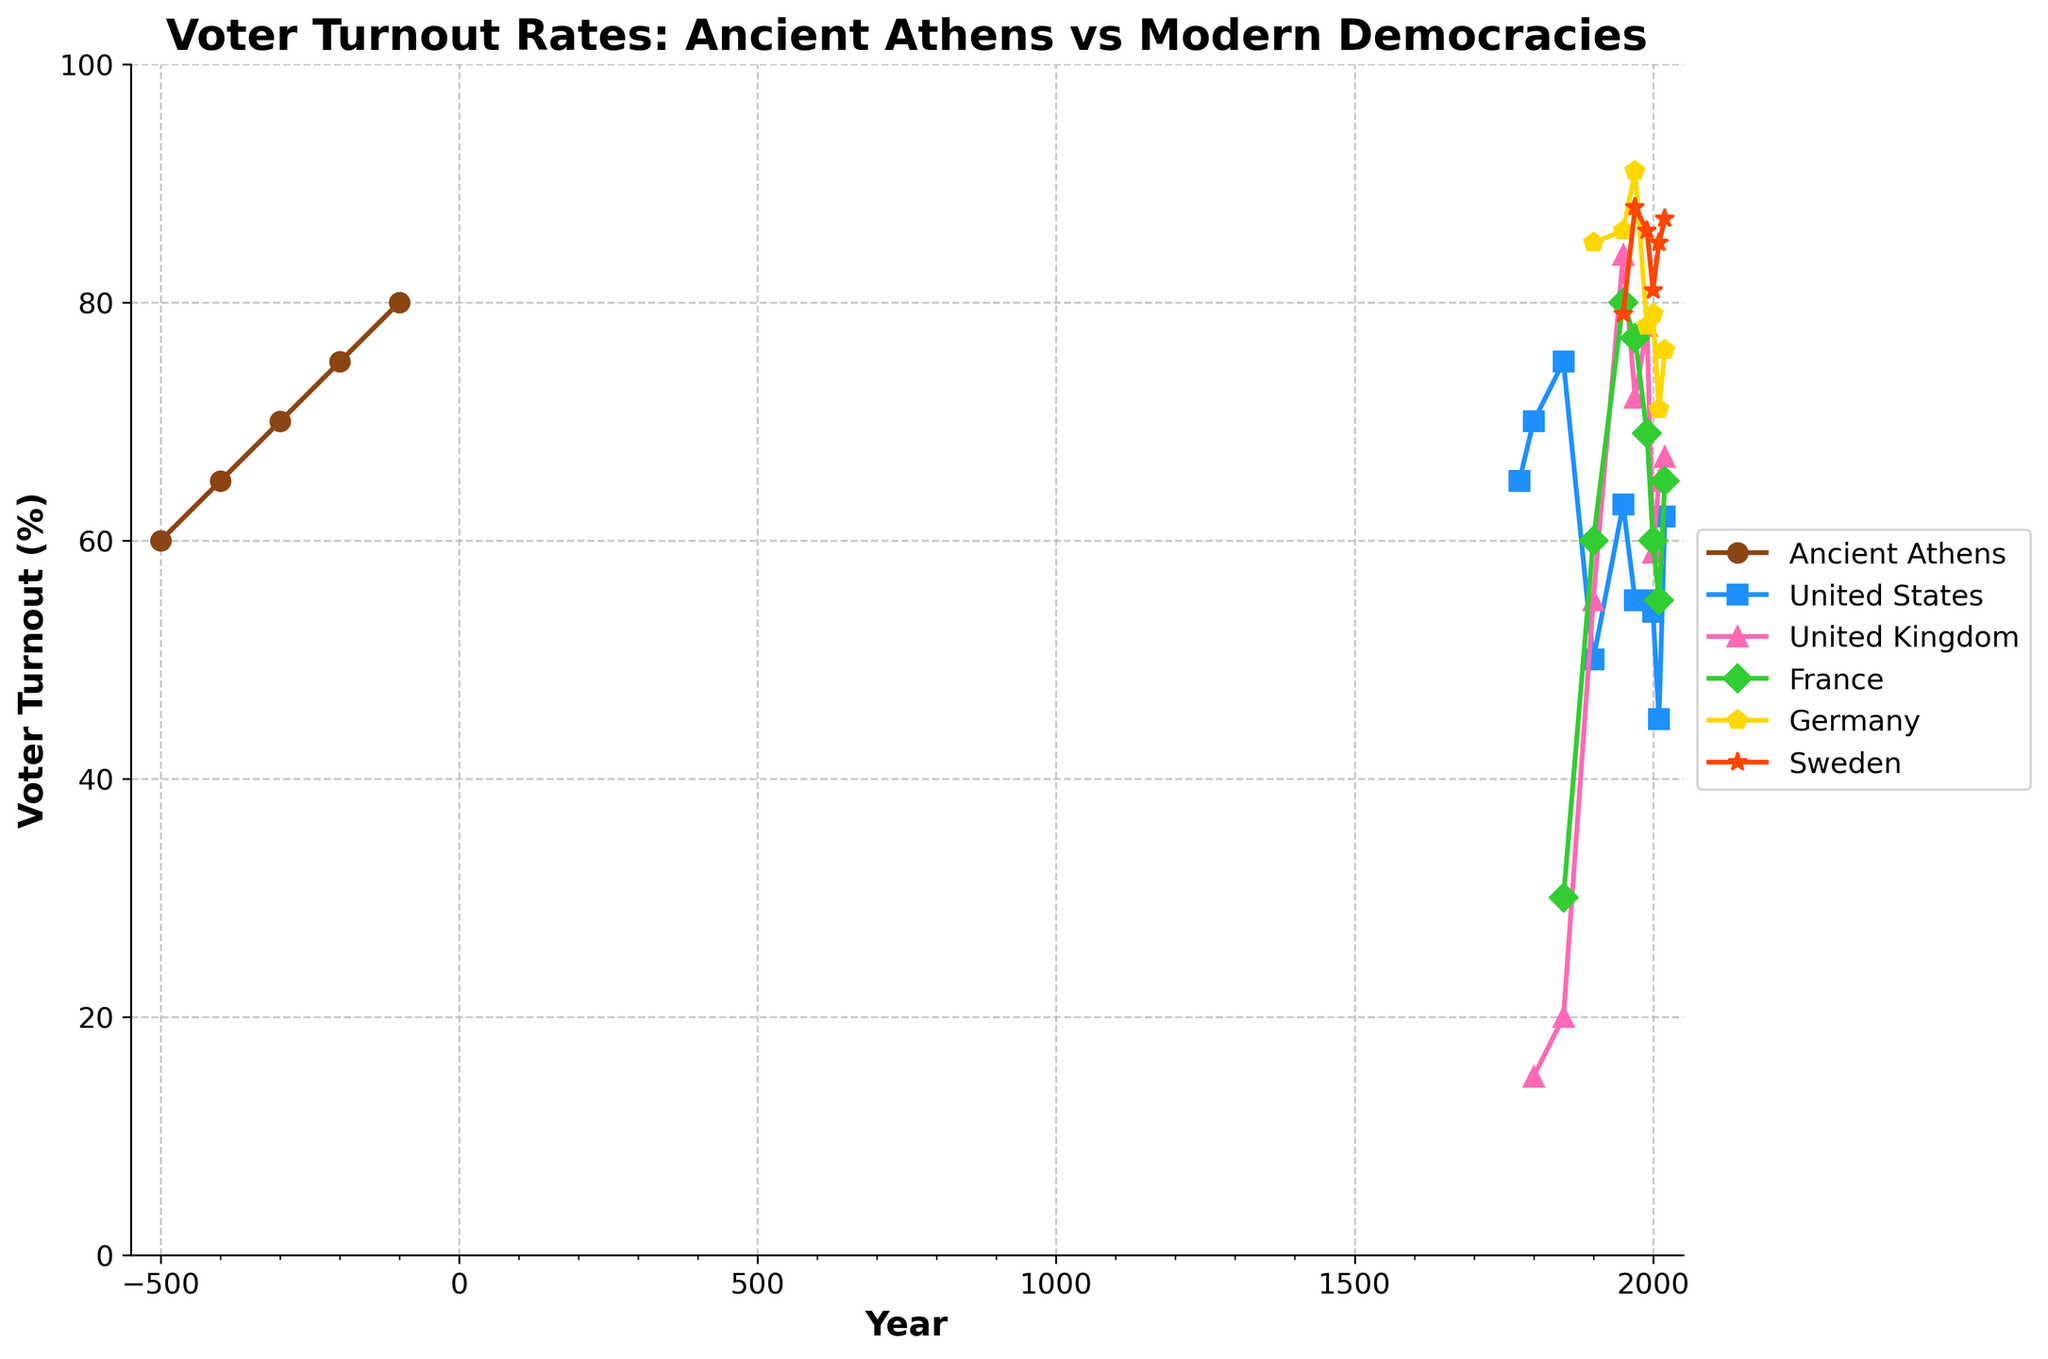What's the trend of voter turnout in Ancient Athens over time? The voter turnout in Ancient Athens shows a consistent increase over the years. Starting from 60% at 500 BCE, it gradually increases to 80% by 100 BCE.
Answer: Increasing Between 1900 and 2020, which country experienced the largest decrease in voter turnout? Comparing the voter turnouts, the United States had 50% in 1900 and 62% in 2020. The United Kingdom had 55% in 1900 and 67% in 2020. France had 60% in 1900 and 65% in 2020. Germany had 85% in 1900 and 76% in 2020. Sweden had 79% in 1900 and 87% in 2020. The United States showed the largest decrease, from 50% in 1900 to 45% in 2010, a drop of 5%.
Answer: United States Which modern democracy had the highest voter turnout in 1950? In 1950, voter turnout rates were as follows: United States 63%, United Kingdom 84%, France 80%, Germany 86%, Sweden 79%. Germany had the highest voter turnout at 86%.
Answer: Germany How does the voter turnout trend in Ancient Athens compare to the trend in the United States? Ancient Athens showed a consistent increase from 60% to 80%, while the United States had fluctuating values, starting at 65% in 1776, going through a decline to 45% in 2010, and then rising to 62% in 2020. Ancient Athens shows a consistently increasing trend, while the United States shows a fluctuating trend with an overall decline.
Answer: Ancient Athens: Increasing, United States: Fluctuating During which period did voter turnout in Sweden remain above 80%? In Sweden, voter turnout remained above 80% continuously from 1950 onwards, with values of 79%, 88%, 86%, 81%, 85%, and 87% respectively, with 79% in 1950 being very close to but just below 80%.
Answer: 1950 onwards How did voter turnout in France change from 1900 to 2020? In France, voter turnout was 60% in 1900, increased to 80% by 1950, fluctuated between 77% in 1970, 69% in 1990, and then declined to 55% in 2010, finally rising to 65% in 2020.
Answer: Initial Increase, then fluctuating Between 1950 and 2000, which country experienced the smallest change in voter turnout? Comparing the values between 1950 and 2000: United States (63% to 54%, change of 9%), United Kingdom (84% to 59%, change of 25%), France (80% to 60%, change of 20%), Germany (86% to 79%, change of 7%), and Sweden (79% to 81%, change of 2%). Sweden experienced the smallest change, from 79% to 81%, a change of only 2%.
Answer: Sweden What is the average voter turnout in Ancient Athens for the provided years? Adding the voter turnout percentages for Ancient Athens (60%, 65%, 70%, 75%, 80%) and dividing by the number of data points (5), the average is (60 + 65 + 70 + 75 + 80) / 5 = 70%.
Answer: 70% Which two modern countries had the most similar voter turnout trends between 1990 and 2020? The United States and Germany had voter turnout rates of US: 55%, 54%, 45%, 62%; Germany: 78%, 79%, 71%, 76%. Both countries experienced similar fluctuating trends between 1990 and 2020.
Answer: United States and Germany What was the voter turnout trend in the United Kingdom from 1850 to 2020? In the United Kingdom, voter turnout was 20% in 1850, which steadily increased to 55% in 1900, then to 84% in 1950. It then decreased to 72% in 1970, rose to 78% in 1990 and then fluctuated around 67% to 65% in 2020.
Answer: Increasing, then fluctuating 